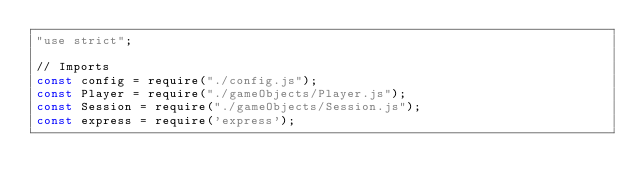<code> <loc_0><loc_0><loc_500><loc_500><_JavaScript_>"use strict";

// Imports
const config = require("./config.js");
const Player = require("./gameObjects/Player.js");
const Session = require("./gameObjects/Session.js");
const express = require('express');</code> 